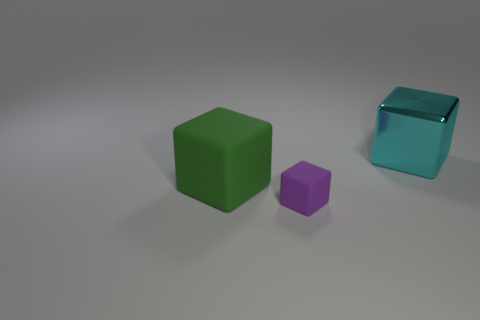Add 2 tiny red matte cylinders. How many objects exist? 5 Subtract 0 brown cylinders. How many objects are left? 3 Subtract all small red rubber spheres. Subtract all matte cubes. How many objects are left? 1 Add 2 small purple rubber objects. How many small purple rubber objects are left? 3 Add 3 small purple cubes. How many small purple cubes exist? 4 